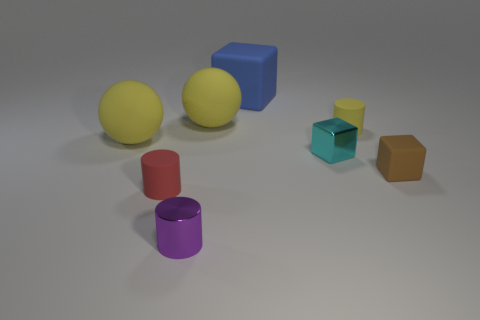Are there fewer matte cylinders than tiny blue metal spheres?
Offer a terse response. No. Is there a cyan metal cube of the same size as the brown cube?
Keep it short and to the point. Yes. There is a cyan object; does it have the same shape as the large blue matte object that is behind the small purple cylinder?
Ensure brevity in your answer.  Yes. What number of balls are small objects or tiny cyan metallic objects?
Provide a succinct answer. 0. What color is the metal block?
Provide a short and direct response. Cyan. Are there more big cyan blocks than big blue matte blocks?
Your answer should be very brief. No. How many things are small rubber objects that are to the right of the purple shiny cylinder or cyan metal things?
Your answer should be compact. 3. Does the purple thing have the same material as the cyan cube?
Offer a very short reply. Yes. What is the size of the cyan object that is the same shape as the large blue thing?
Give a very brief answer. Small. There is a big thing that is left of the red rubber object; is its shape the same as the rubber object that is in front of the brown cube?
Offer a very short reply. No. 